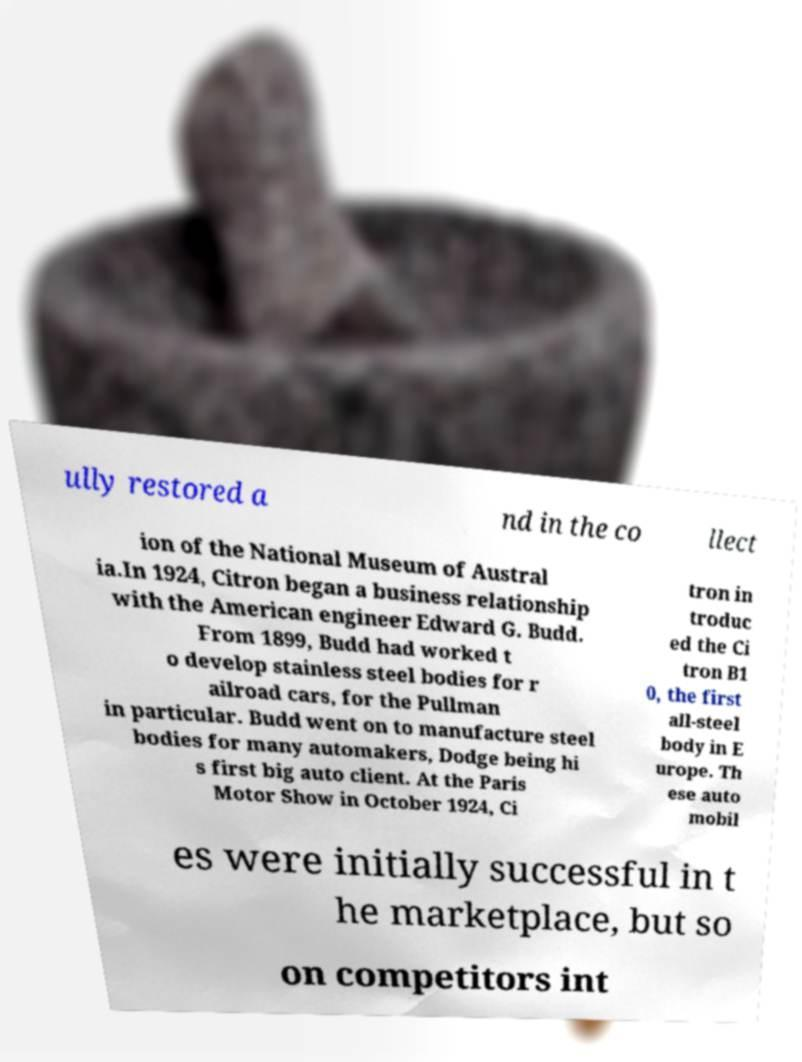I need the written content from this picture converted into text. Can you do that? ully restored a nd in the co llect ion of the National Museum of Austral ia.In 1924, Citron began a business relationship with the American engineer Edward G. Budd. From 1899, Budd had worked t o develop stainless steel bodies for r ailroad cars, for the Pullman in particular. Budd went on to manufacture steel bodies for many automakers, Dodge being hi s first big auto client. At the Paris Motor Show in October 1924, Ci tron in troduc ed the Ci tron B1 0, the first all-steel body in E urope. Th ese auto mobil es were initially successful in t he marketplace, but so on competitors int 